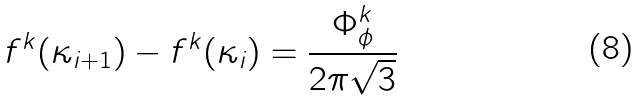Convert formula to latex. <formula><loc_0><loc_0><loc_500><loc_500>f ^ { k } ( \kappa _ { i + 1 } ) - f ^ { k } ( \kappa _ { i } ) = \frac { \Phi ^ { k } _ { \phi } } { 2 \pi \sqrt { 3 } }</formula> 